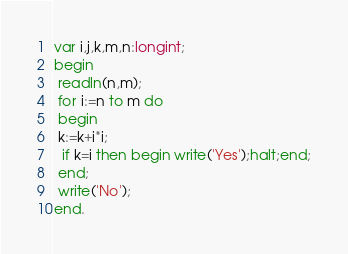<code> <loc_0><loc_0><loc_500><loc_500><_Pascal_>var i,j,k,m,n:longint;
begin
 readln(n,m);
 for i:=n to m do
 begin
 k:=k+i*i;
  if k=i then begin write('Yes');halt;end;
 end;
 write('No');
end.
</code> 